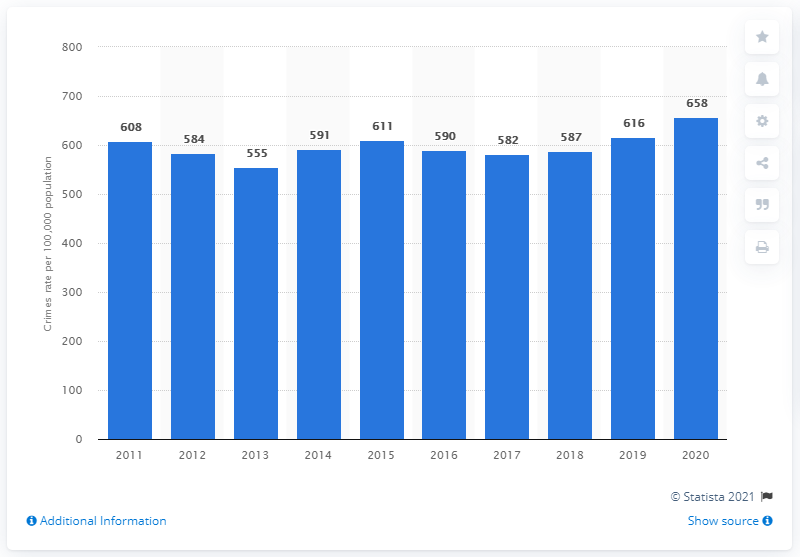Specify some key components in this picture. In the year 2020, there were 658 crimes committed per 100,000 individuals in Singapore. The crime rate in Singapore in 2020 was approximately 658 crimes per 100,000 people. 